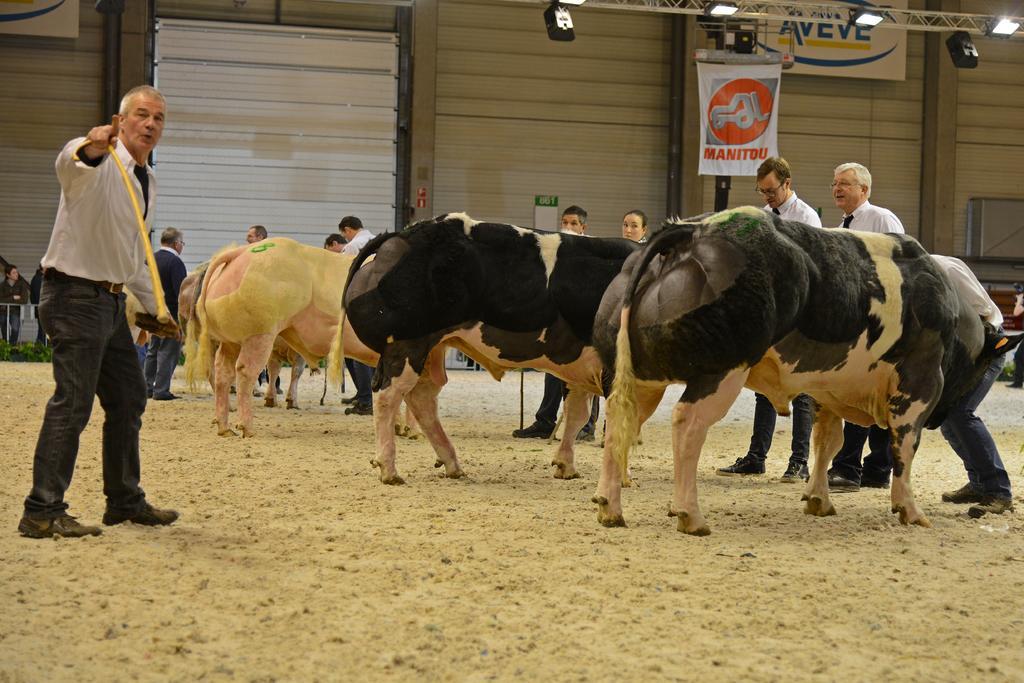Describe this image in one or two sentences. In this picture we can see a group of people and animals on the ground and in the background we can see a banner, boards, wall, lights and some objects. 